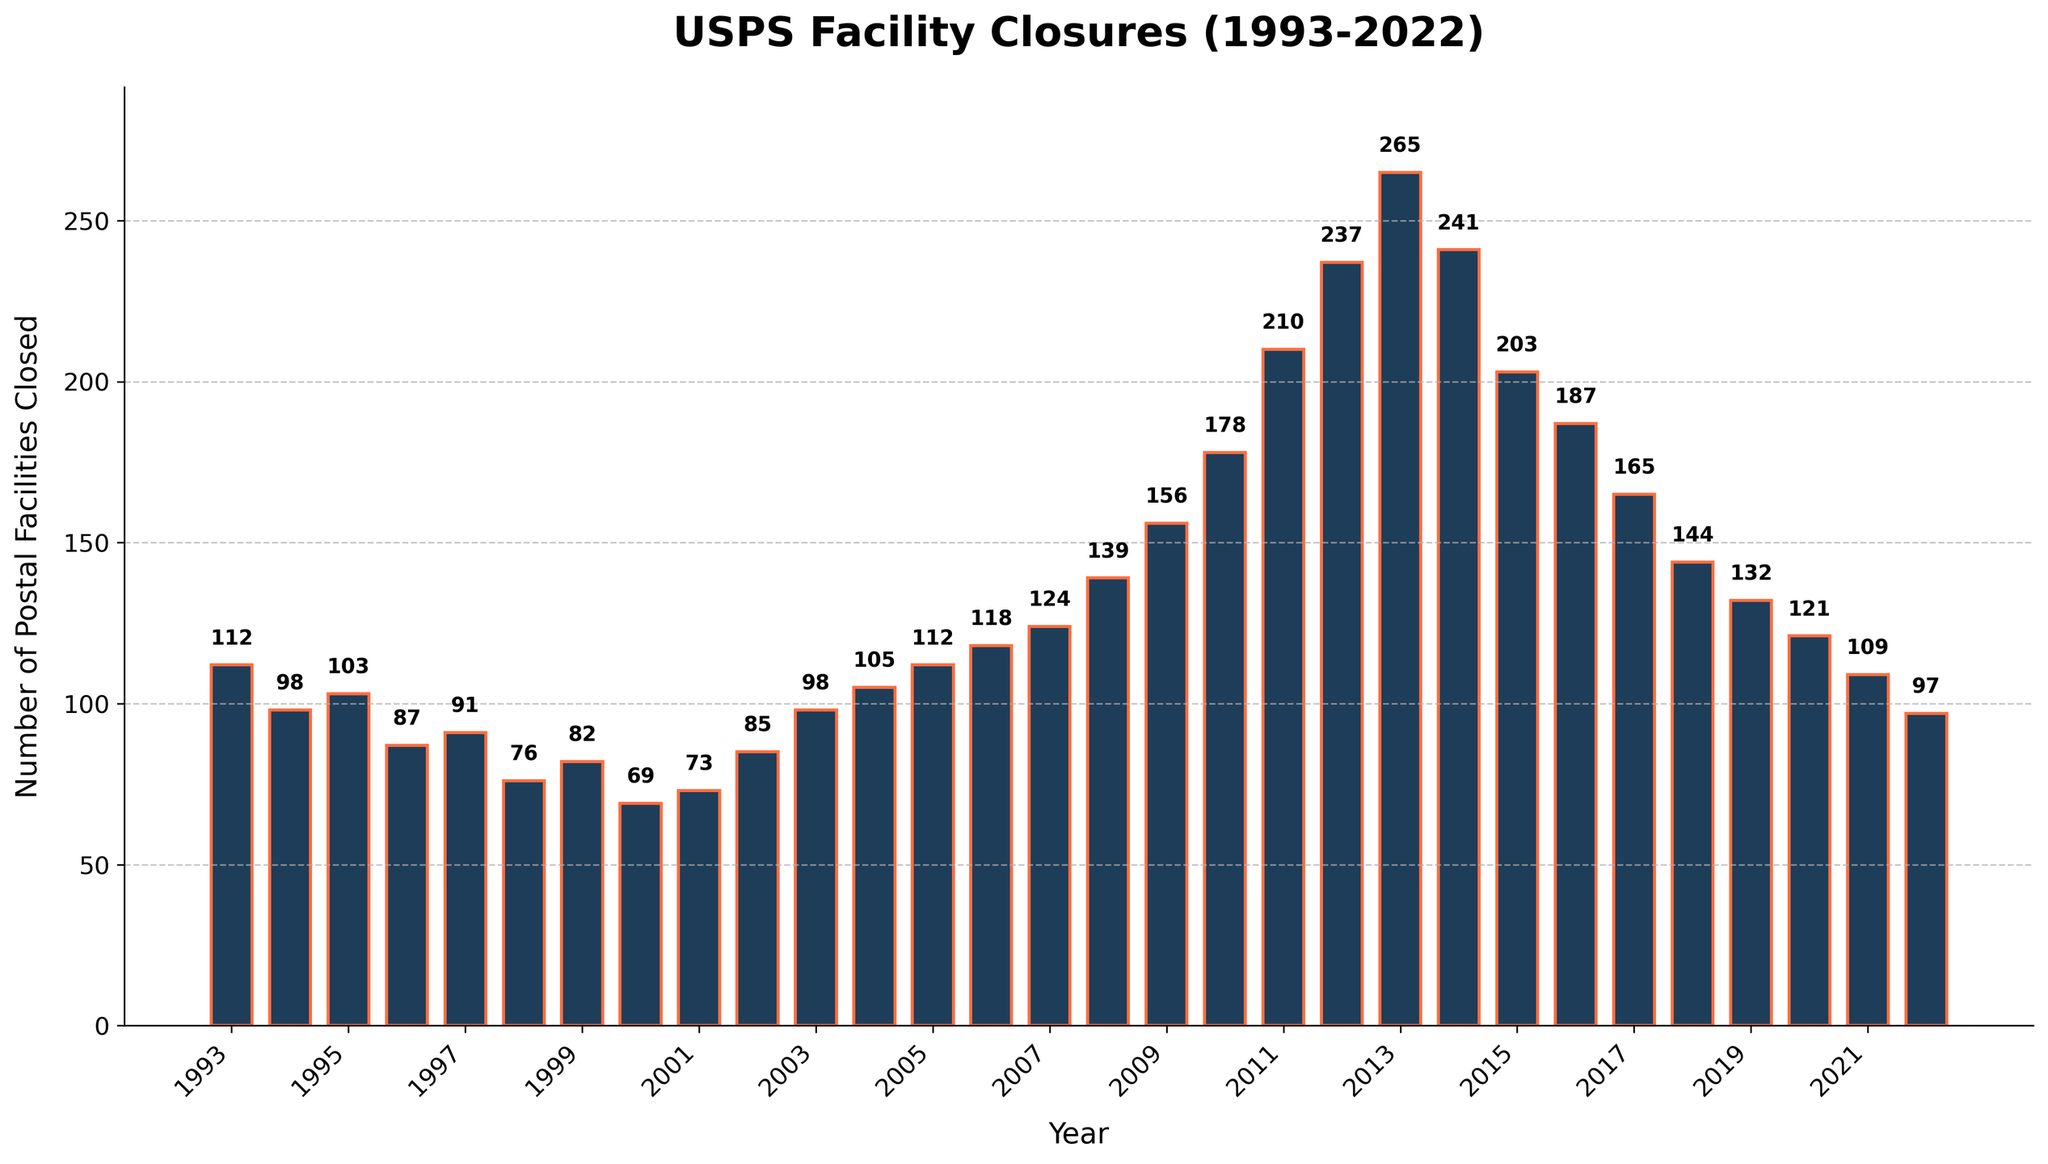What year experienced the highest number of postal facilities closed? Look at the bars and identify the tallest one. The highest bar represents the year with the most closures.
Answer: 2013 Which year had fewer closures, 2005 or 2022? Compare the height of the bars for 2005 and 2022. The bar that is shorter represents the year with fewer closures.
Answer: 2022 What is the average number of postal facilities closed between 2010 and 2015? Sum the values of postal facilities closed from 2010 to 2015 and divide by the number of years (6). (178+210+237+265+241+203) = 1334; 1334/6
Answer: 222.33 Is there a consistent trend in the number of closures from 1993 to 2022? Examine the bars from left to right and see if they show a general increase, decrease, or if they fluctuate. The bars show an increase over time, particularly steep in the years between 2010 and 2013, followed by a decrease.
Answer: General increase, then decrease after 2013 By how much did the number of closures increase from 2007 to 2009? Subtract the number of closures in 2007 from the number of closures in 2009. (156 - 124)
Answer: 32 How many more postal facilities were closed in 2013 compared to 2020? Compare the number of closures in 2013 and 2020, and subtract the lesser value from the greater one. (265 - 121)
Answer: 144 Which decade had more closures, the 1990s or the 2010s? Sum the closures for each decade separately (1990s: 1993-1999, 2010s: 2010-2019), and compare the totals. 1990s total = 112+98+103+87+91+76+82 = 649, 2010s total = 178+210+237+265+241+203+187+165+144+132 = 1962
Answer: 2010s Which year had the second-highest number of closures? Identify the tallest bar, then find the second tallest. 2013 is the highest with 265 closures, the next highest is 2014 with 241 closures.
Answer: 2014 How did the number of closures change from 1993 to 2022? Identify the values for the two years and subtract the 2022 value from the 1993 value. (112 - 97)
Answer: Decreased by 15 